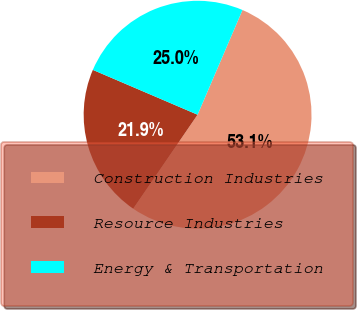<chart> <loc_0><loc_0><loc_500><loc_500><pie_chart><fcel>Construction Industries<fcel>Resource Industries<fcel>Energy & Transportation<nl><fcel>53.11%<fcel>21.88%<fcel>25.01%<nl></chart> 